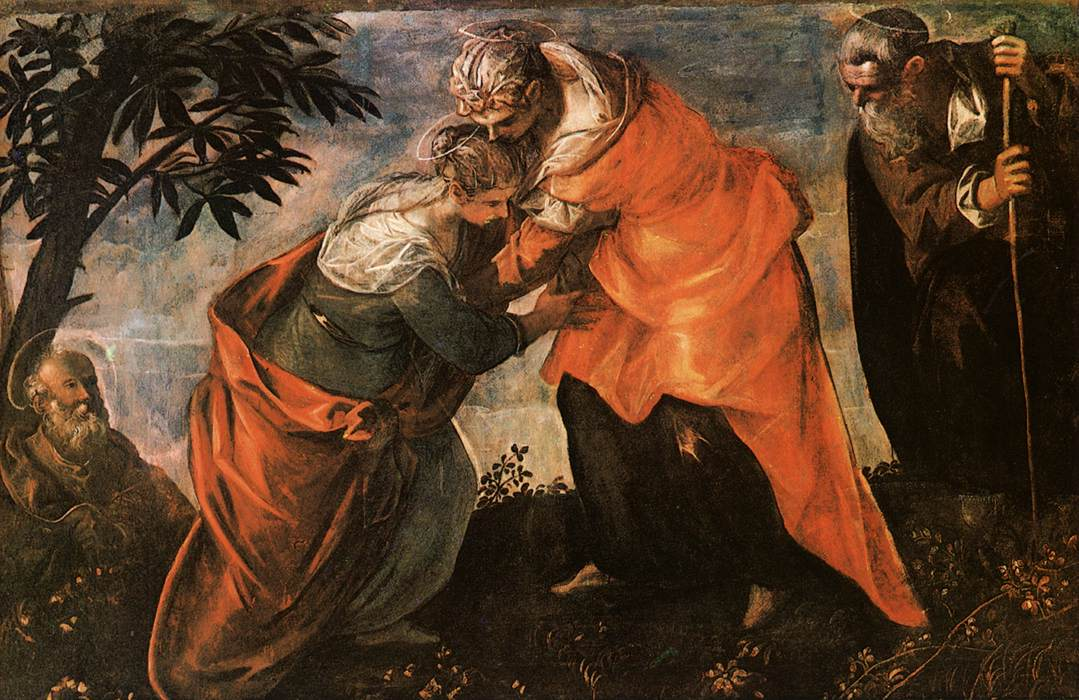If this garden could tell stories of the people who visited it, what would it say? In hushed whispers, the garden would recount tales of hope and divine encounters. It would tell of Mary's humble yet profound journey, braving her way to see Elizabeth, seeking comfort and connection. Elizabeth, with her own miracle within, would be remembered for her joy and affirmation, a sanctuary of solace. The trees would share of their witnessing two women discussing their divine purposes, exchanging assurances and experiencing deep, spiritual bonds. Under the caress of gentle breezes, it would also reminisce about the hush that fell over the world as these two great destinies intertwined. What other mysteries might the trees and plants of this garden hold about this encounter? The trees and plants could whisper of the unseen figures, like angels, who adorned the garden with an ethereal presence, unseen but felt in the tranquility that wrapped around Mary and Elizabeth. They might murmur about the moments of quiet prayer that filled the garden, the whispered reassurances in moments of doubt, and the ethereal light that bathed them, symbolizing a divine blessing. The foliage, deeply rooted in the sacred soil, might hold centuries-old secrets, connecting humanity with the divine, a silent witness to God's plan unfolding through the humble lives of His chosen ones. 